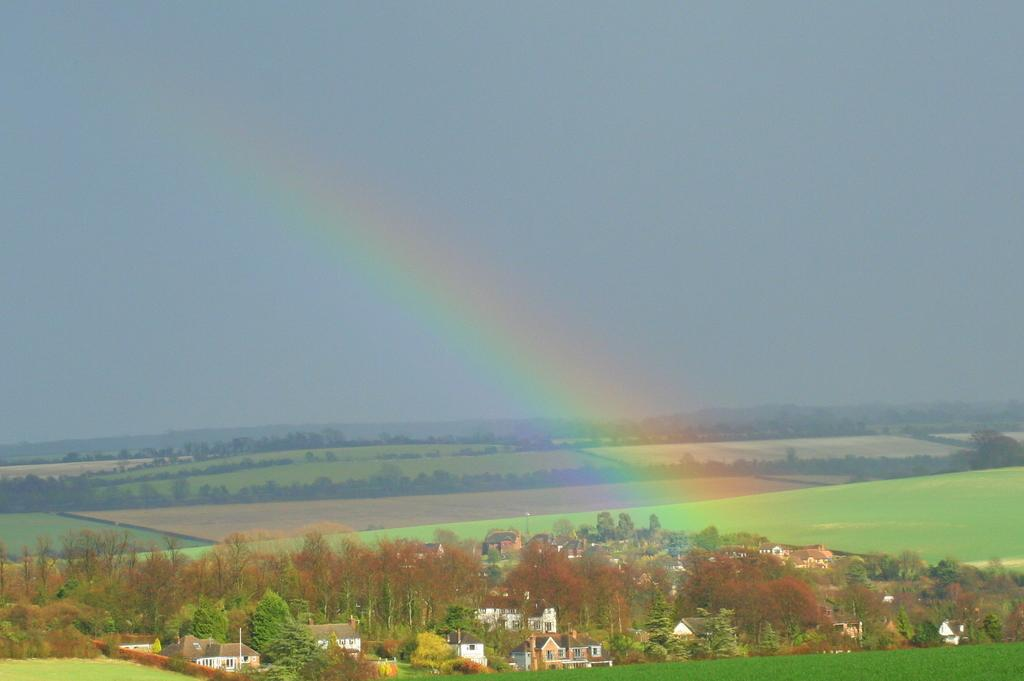What type of structures can be seen in the image? There are buildings in the image. What type of vegetation is present in the image? There are trees in the image, and grass is visible as well. What can be seen in the background of the image? The sky is visible in the background of the image. What additional feature is present in the image? There is a rainbow in the image. How many ghosts can be seen interacting with the buildings in the image? There are no ghosts present in the image; it features buildings, trees, grass, sky, and a rainbow. What type of clocks are visible on the trees in the image? There are no clocks present on the trees in the image; it only features buildings, trees, grass, sky, and a rainbow. 